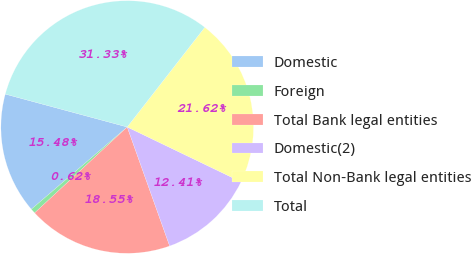<chart> <loc_0><loc_0><loc_500><loc_500><pie_chart><fcel>Domestic<fcel>Foreign<fcel>Total Bank legal entities<fcel>Domestic(2)<fcel>Total Non-Bank legal entities<fcel>Total<nl><fcel>15.48%<fcel>0.62%<fcel>18.55%<fcel>12.41%<fcel>21.62%<fcel>31.33%<nl></chart> 